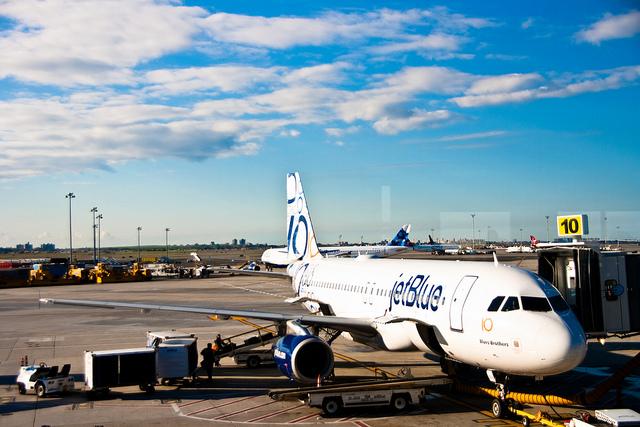What gate is the plane parked at?
Answer briefly. 10. What airline owns this plane?
Short answer required. Jetblue. Did the plane just land?
Be succinct. No. What does this plane have written on it?
Be succinct. Jetblue. What low cost airline is this plane with?
Short answer required. Jetblue. What letters are on the airplane?
Quick response, please. Jetblue. What airlines owns the nearest plane?
Be succinct. Jetblue. 